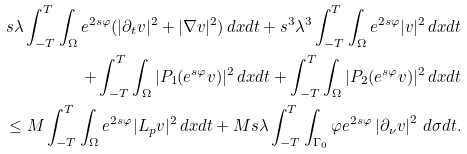<formula> <loc_0><loc_0><loc_500><loc_500>s \lambda \int _ { - T } ^ { T } \int _ { \Omega } e ^ { 2 s \varphi } ( | \partial _ { t } v | ^ { 2 } + | \nabla v | ^ { 2 } ) \, d x d t + s ^ { 3 } \lambda ^ { 3 } \int _ { - T } ^ { T } \int _ { \Omega } e ^ { 2 s \varphi } | v | ^ { 2 } \, d x d t \\ + \int _ { - T } ^ { T } \int _ { \Omega } | P _ { 1 } ( e ^ { s \varphi } v ) | ^ { 2 } \, d x d t + \int _ { - T } ^ { T } \int _ { \Omega } | P _ { 2 } ( e ^ { s \varphi } v ) | ^ { 2 } \, d x d t \\ \leq M \int _ { - T } ^ { T } \int _ { \Omega } e ^ { 2 s \varphi } | L _ { p } v | ^ { 2 } \, d x d t + M s \lambda \int _ { - T } ^ { T } \int _ { \Gamma _ { 0 } } \varphi e ^ { 2 s \varphi } \left | \partial _ { \nu } v \right | ^ { 2 } \, d \sigma d t .</formula> 